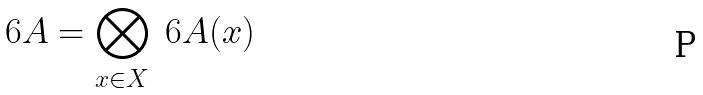<formula> <loc_0><loc_0><loc_500><loc_500>\ 6 A = \bigotimes _ { x \in X } \ 6 A ( x ) \,</formula> 